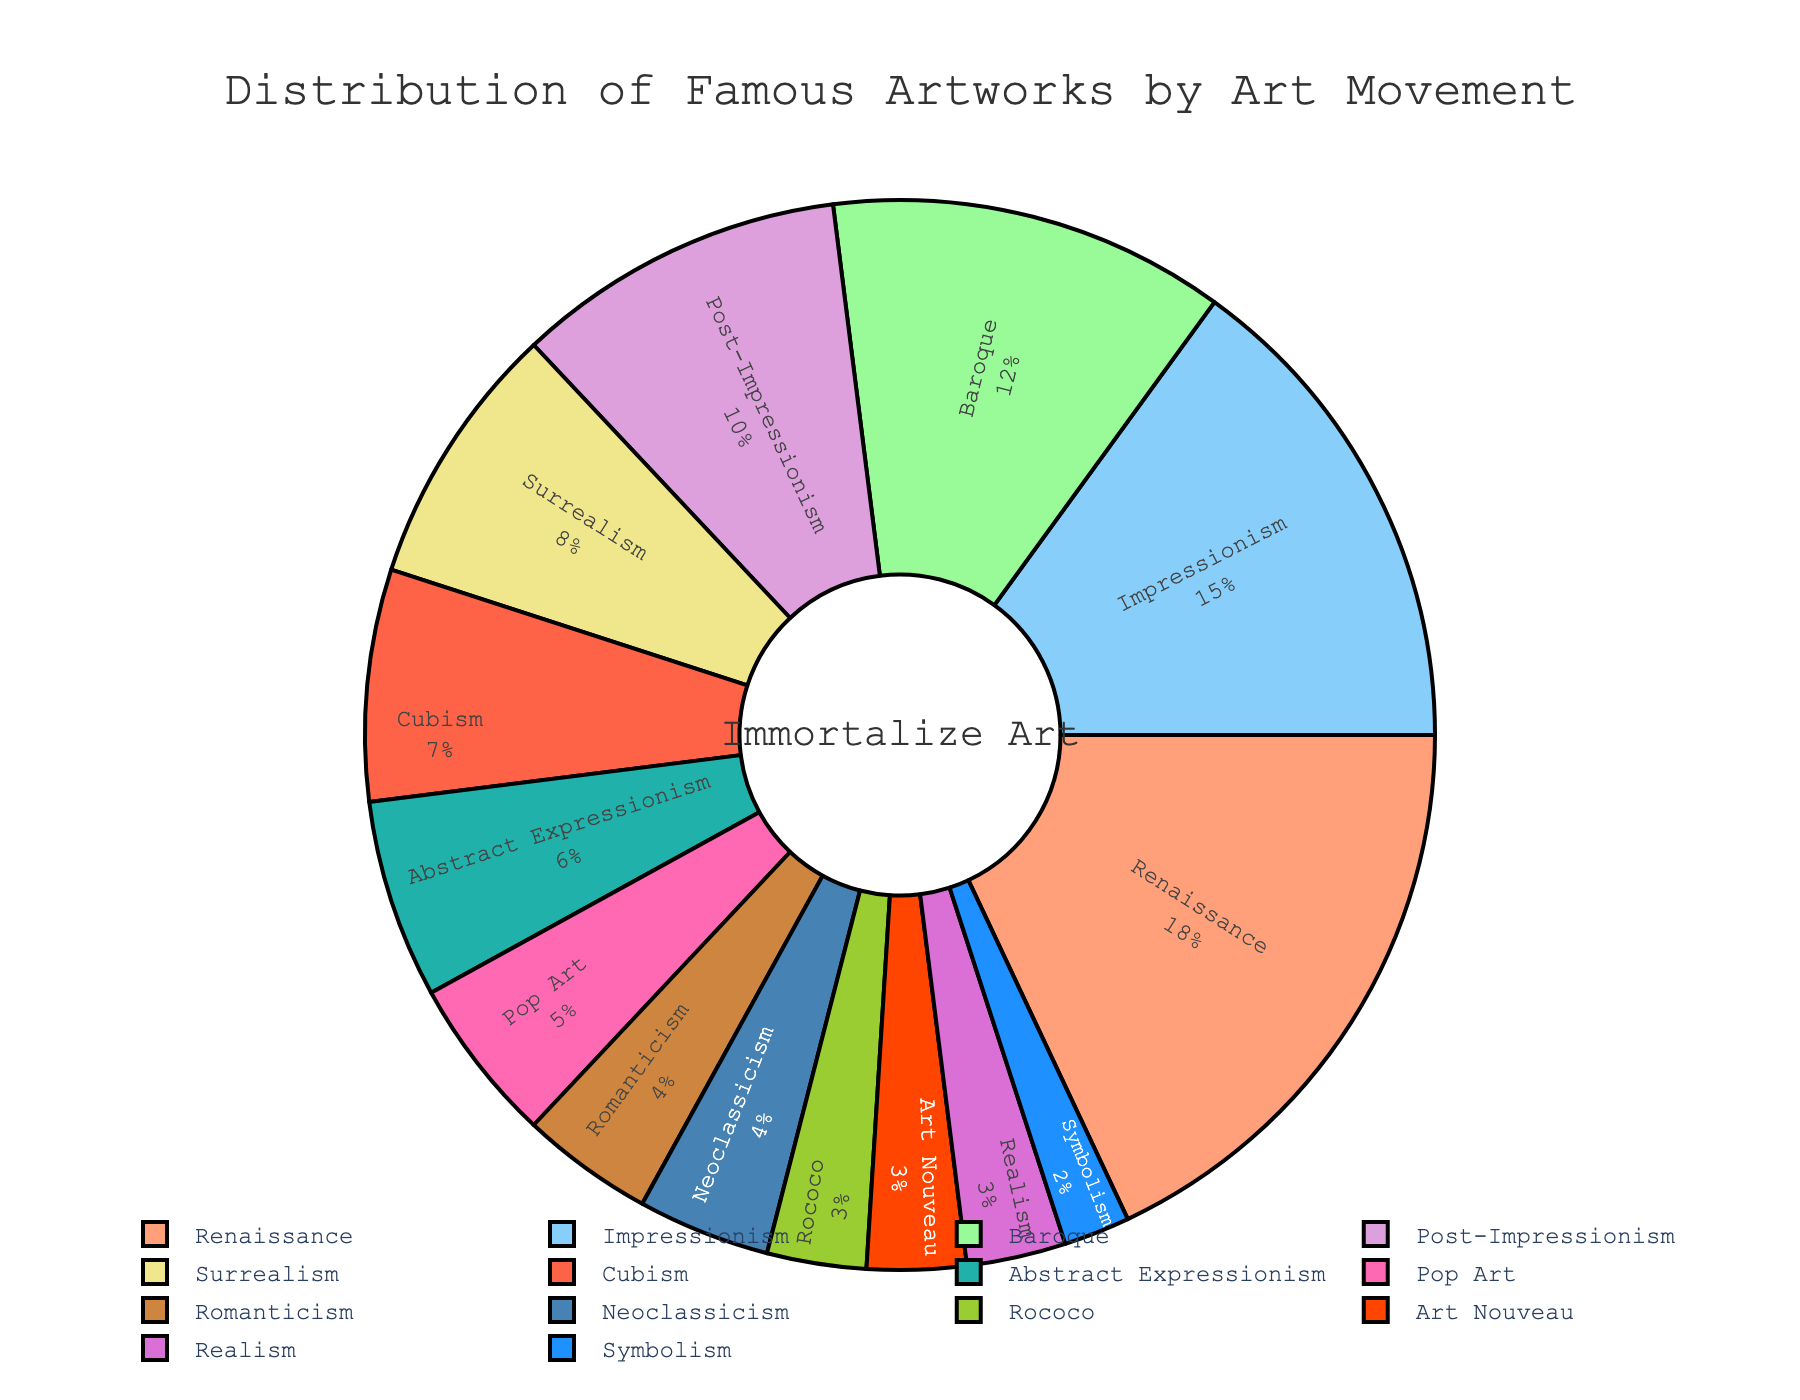What percentage of famous artworks belong to Renaissance and Baroque combined? To find the combined percentage for Renaissance and Baroque, add the individual percentages: 18% for Renaissance and 12% for Baroque. Therefore, 18 + 12 = 30%.
Answer: 30% Which art movement has a higher percentage of famous artworks, Cubism or Surrealism? Compare the percentages of famous artworks: Cubism has 7% and Surrealism has 8%. Therefore, Surrealism has a higher percentage than Cubism.
Answer: Surrealism What is the difference in percentage between Impressionism and Abstract Expressionism? Subtract the percentage of Abstract Expressionism from that of Impressionism: 15% (Impressionism) - 6% (Abstract Expressionism) = 9%.
Answer: 9% What are the three art movements with the lowest percentage of famous artworks? Identify the three art movements with the smallest percentages: Rococo (3%), Art Nouveau (3%), and Symbolism (2%).
Answer: Rococo, Art Nouveau, Symbolism Which art movement occupies the green-colored section of the pie chart? In the pie chart, match the green color to the sector: Photos indicate Rococo is represented by a green color.
Answer: Rococo Among Renaissance, Baroque, and Impressionism, which art movement has the smallest contribution? Compare the percentages: Renaissance (18%), Baroque (12%), and Impressionism (15%). Baroque has the smallest percentage.
Answer: Baroque If Pop Art and Realism are combined, what would be their total contribution percentage? Add the percentages of Pop Art and Realism: 5% (Pop Art) + 3% (Realism) = 8%.
Answer: 8% Which art movement has a sector that is labeled inside and has a percentage shown? All sectors are labeled inside with percentages shown; an example is Renaissance with 18%.
Answer: Renaissance What is the total percentage of artworks in the data set represented by the pie chart? Sum all the given percentages: 18 + 12 + 15 + 10 + 8 + 7 + 6 + 5 + 4 + 4 + 3 + 3 + 3 + 2 = 100%.
Answer: 100% 